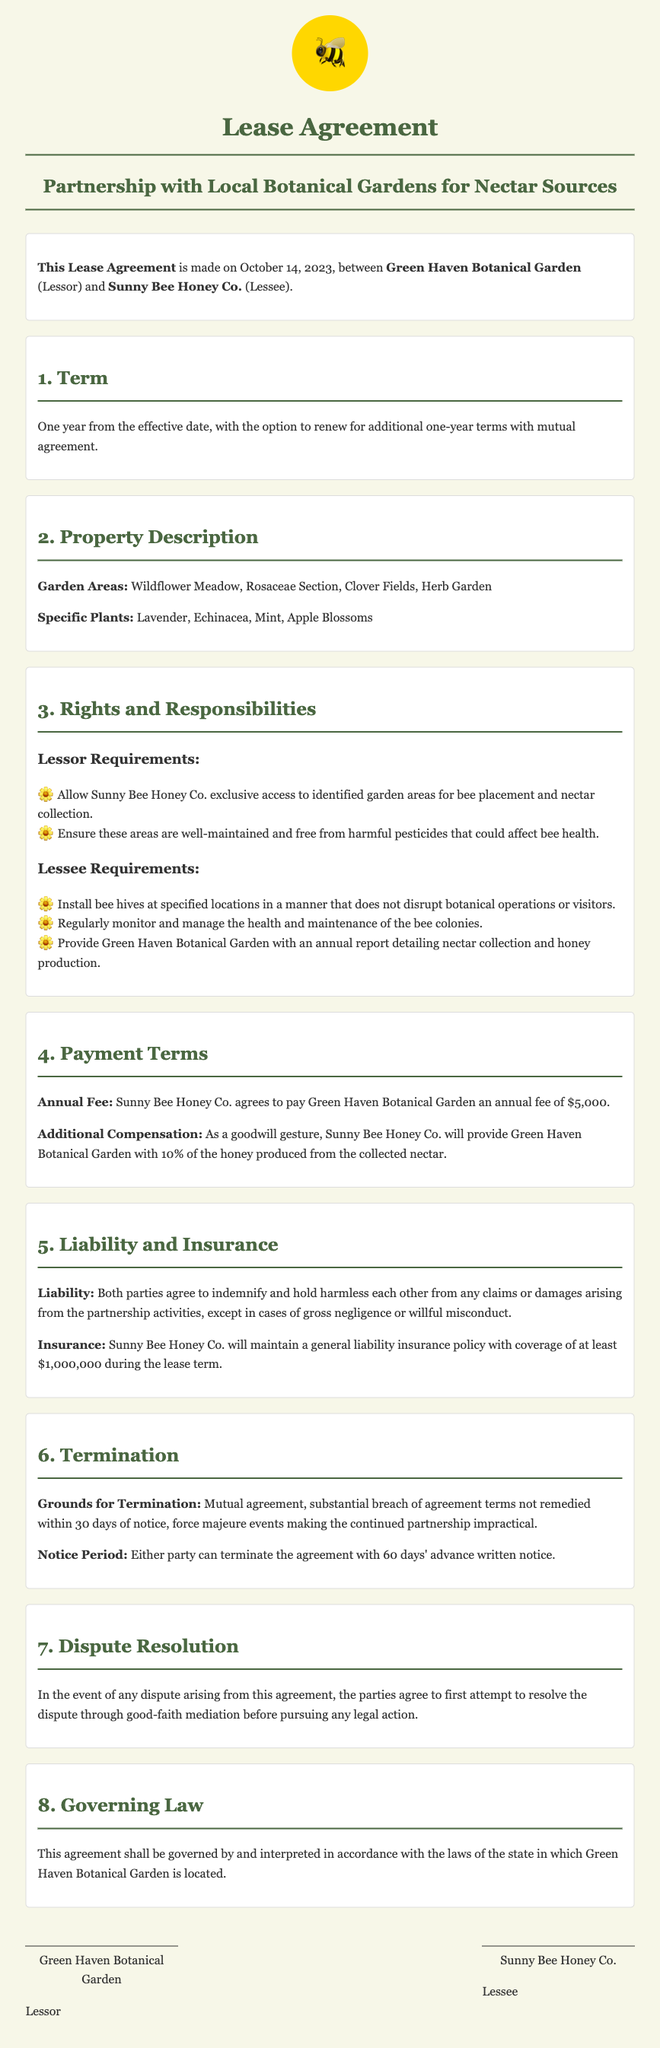What is the effective date of the lease agreement? The effective date is explicitly stated near the beginning of the document.
Answer: October 14, 2023 Who is the lessor in this agreement? The lessor is mentioned in the opening statement of the agreement as the party providing the lease.
Answer: Green Haven Botanical Garden What is the annual fee to be paid by the lessee? The payment terms section specifies the amount to be paid annually.
Answer: $5,000 What specific plant is mentioned in the property description? The document lists specific plants under the property description section.
Answer: Lavender How long is the term of this lease agreement? The term is explicitly stated in the terms section of the document.
Answer: One year What happens if there is a substantial breach of the agreement? The termination section outlines the consequences of a breach.
Answer: Termination How much of the honey produced will be provided to the lessor? The payment terms include a percentage given to the lessor from honey production.
Answer: 10% What is the required insurance coverage amount for the lessee? The insurance section specifies the minimum coverage required for the lessee's insurance policy.
Answer: $1,000,000 What is required of the lessor regarding pesticide use? The responsibilities section for the lessor includes maintenance requirements related to bee health.
Answer: Free from harmful pesticides 